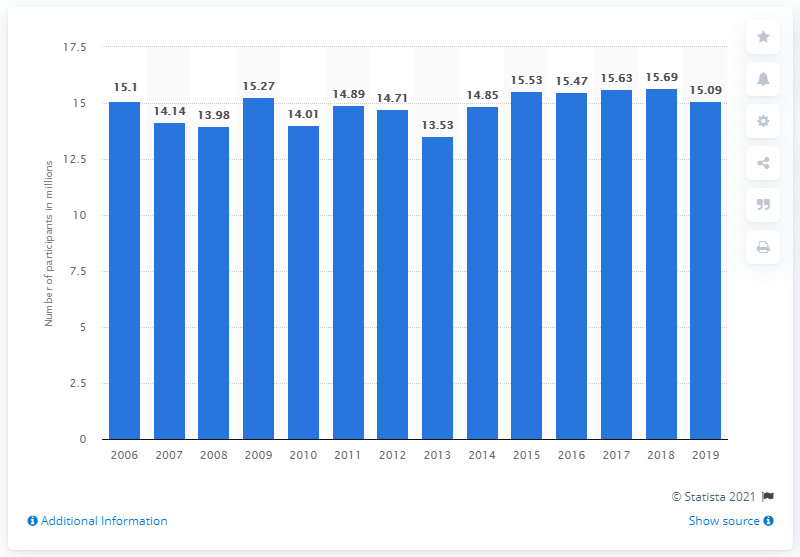List a handful of essential elements in this visual. In the United States in 2019, a total of 15.09 million people participated in hunting. 